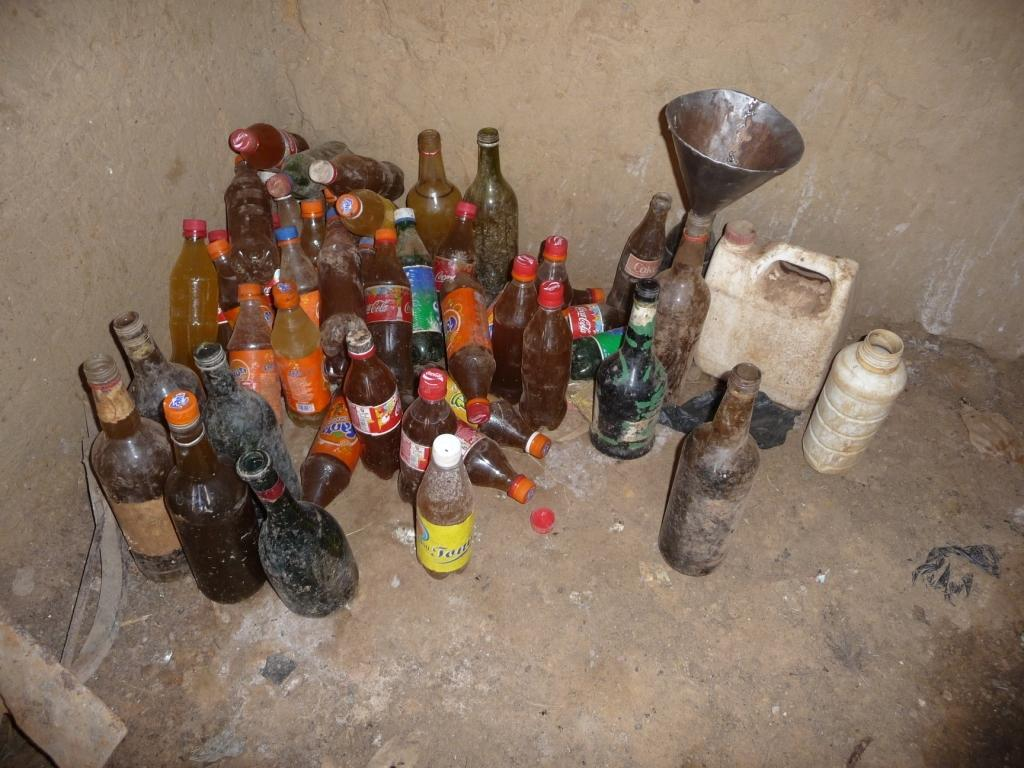What objects are present on the ground in the image? There are bottles on the ground in the image. Can you describe the position of the bottles in the image? The bottles are on the ground in the image. What toys are the bottles playing with in the image? There are no toys present in the image, and the bottles are not playing with anything. 